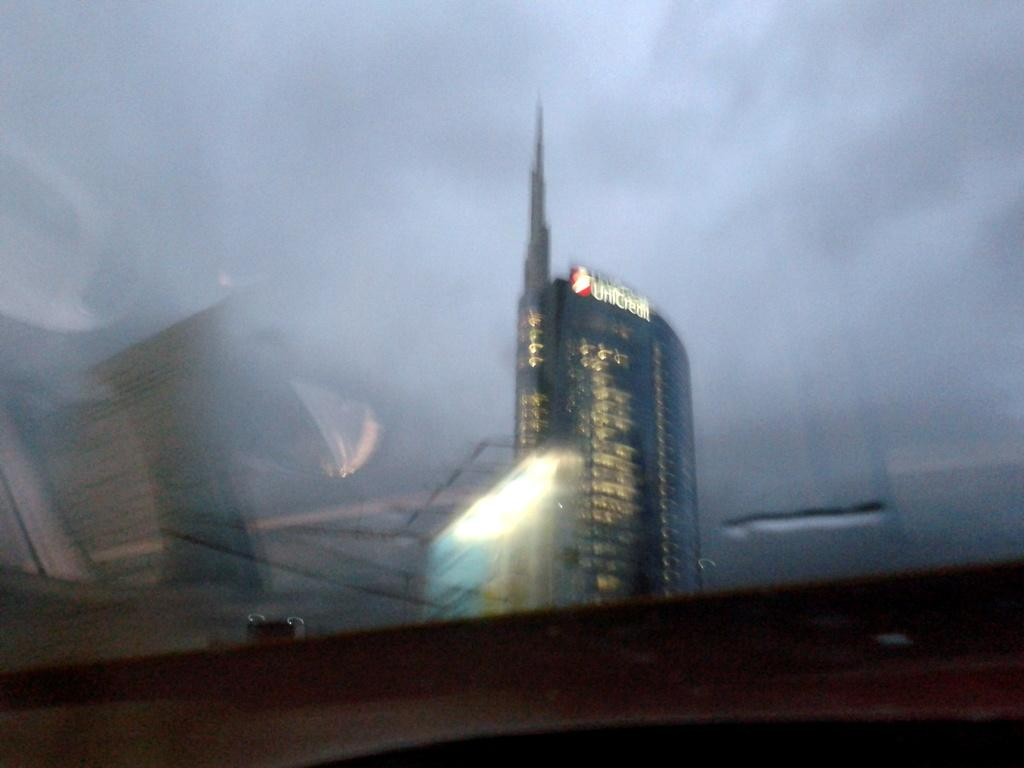What type of structure can be seen in the image? There is a glass window in the image. What is visible in the background of the image? There is a building in the background of the image. What part of the natural environment is visible in the image? The sky is visible in the image. What can be observed in the sky? Clouds are present in the sky. How much profit does the coal mine generate in the image? There is no coal mine or mention of profit in the image; it features a glass window, a building in the background, and clouds in the sky. 